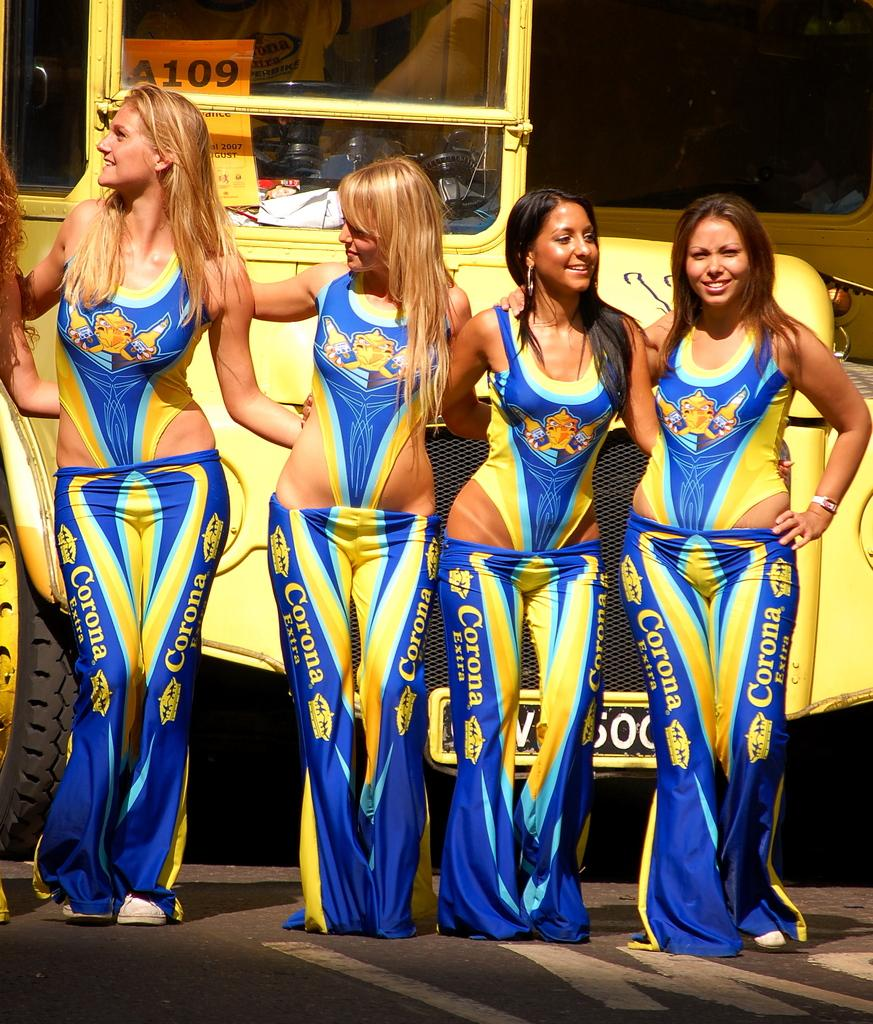<image>
Summarize the visual content of the image. Four girls in bathing suits are wearing low-rise Corona pants. 